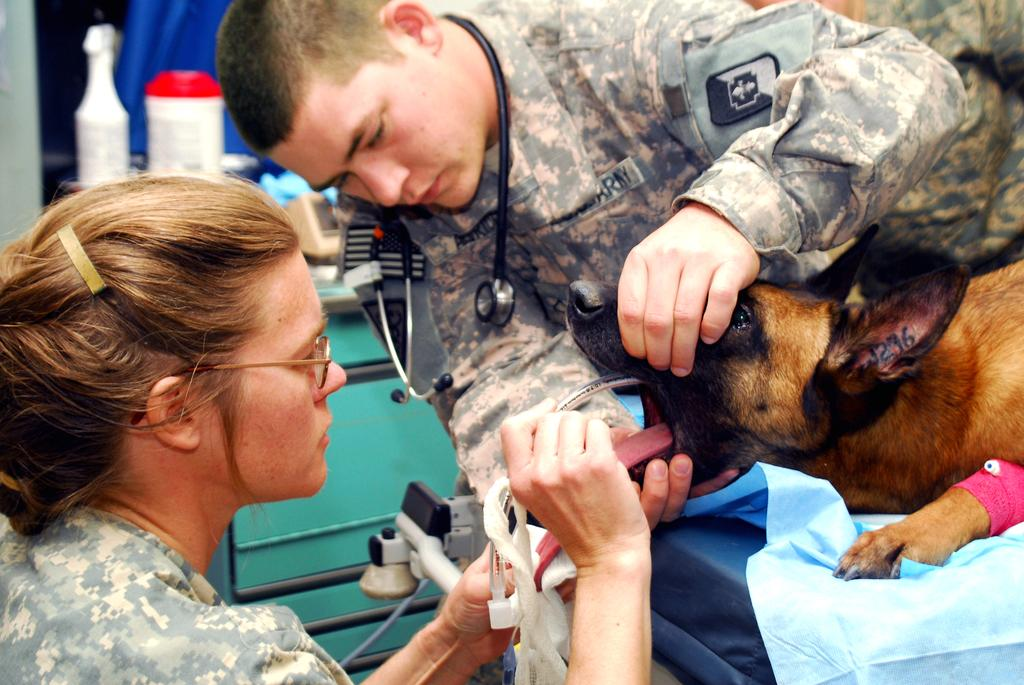How many people are in the image? There are two persons in the image. What is the dog doing in the image? The dog is on the bed. What is one person doing in the image? One person is treating the dog. Can you describe the other person in the image? There is a person holding a dog in the background of the image. What type of poison is the person using to treat the dog in the image? There is no indication in the image that any poison is being used to treat the dog. 